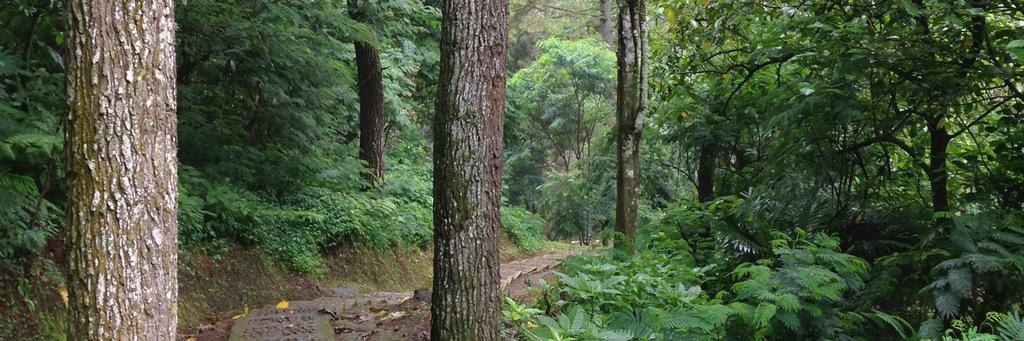Can you describe this image briefly? It is a forest and there are plenty of trees and plants in the forest and in between the plants there is a way. 